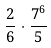<formula> <loc_0><loc_0><loc_500><loc_500>\frac { 2 } { 6 } \cdot \frac { 7 ^ { 6 } } { 5 }</formula> 